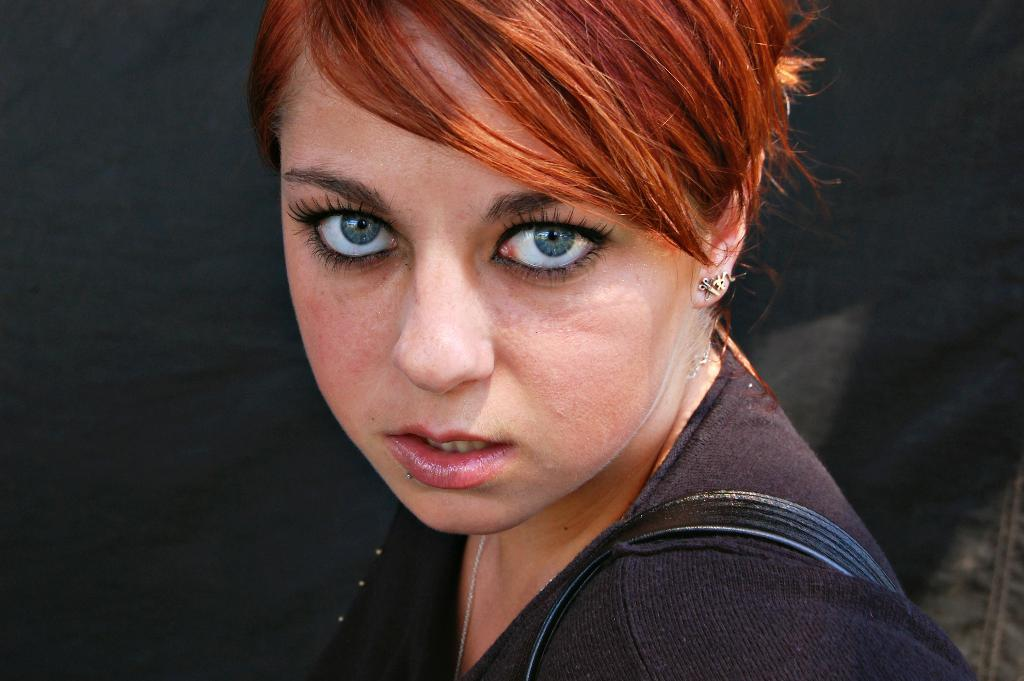Who is the main subject in the image? There is a woman in the image. What can be observed about the woman's eyes? The woman has blue eyes. What is the color of the woman's hair? The woman's hair is brown. How is the background of the image depicted? The background of the woman is blurred. What type of spy equipment can be seen in the woman's hand in the image? There is no spy equipment visible in the woman's hand in the image. Is the woman driving a vehicle in the image? There is no vehicle present in the image, and the woman is not depicted as driving. 